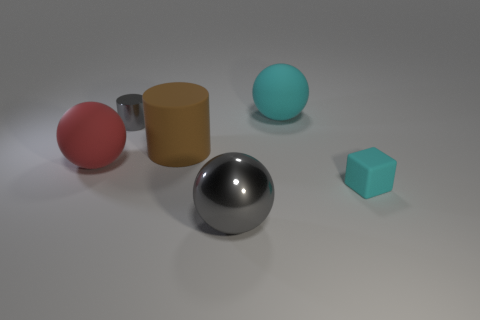Is there anything else that is the same shape as the tiny cyan matte object?
Your answer should be compact. No. There is another object that is the same shape as the tiny gray object; what color is it?
Provide a short and direct response. Brown. What number of big objects are both in front of the tiny gray cylinder and to the right of the red ball?
Keep it short and to the point. 2. Is the number of matte things behind the small cylinder greater than the number of brown cylinders that are in front of the red thing?
Offer a terse response. Yes. What size is the red rubber sphere?
Offer a very short reply. Large. Is there a large cyan thing of the same shape as the large gray thing?
Make the answer very short. Yes. Does the small metallic object have the same shape as the cyan matte object in front of the red sphere?
Your answer should be very brief. No. There is a ball that is both behind the big gray thing and in front of the cyan rubber sphere; what is its size?
Your answer should be compact. Large. How many large cylinders are there?
Your answer should be very brief. 1. There is a gray thing that is the same size as the cyan rubber ball; what material is it?
Keep it short and to the point. Metal. 